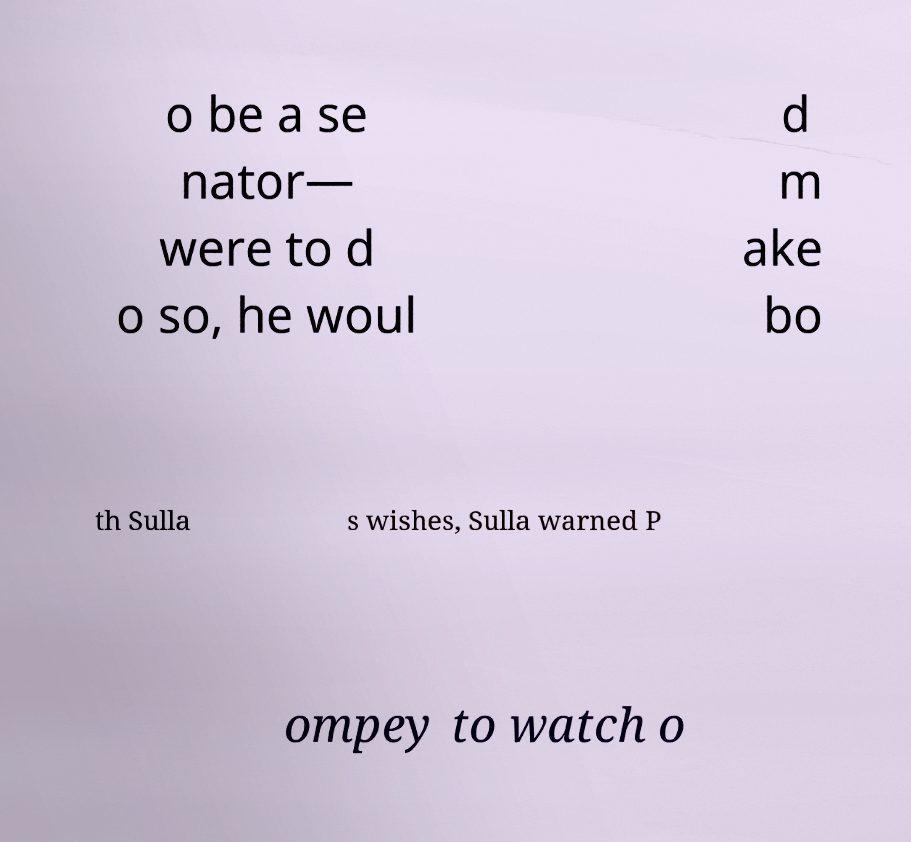Could you extract and type out the text from this image? o be a se nator— were to d o so, he woul d m ake bo th Sulla s wishes, Sulla warned P ompey to watch o 